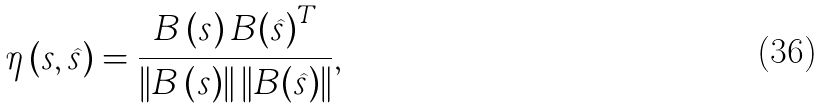Convert formula to latex. <formula><loc_0><loc_0><loc_500><loc_500>\eta \left ( { { s } , \widehat { s } } \right ) = \frac { { { B } \left ( { s } \right ) { B } { { \left ( { \widehat { s } } \right ) } ^ { T } } } } { { \left \| { { B } \left ( { s } \right ) } \right \| \left \| { { B } { { \left ( { \widehat { s } } \right ) } } } \right \| } } ,</formula> 